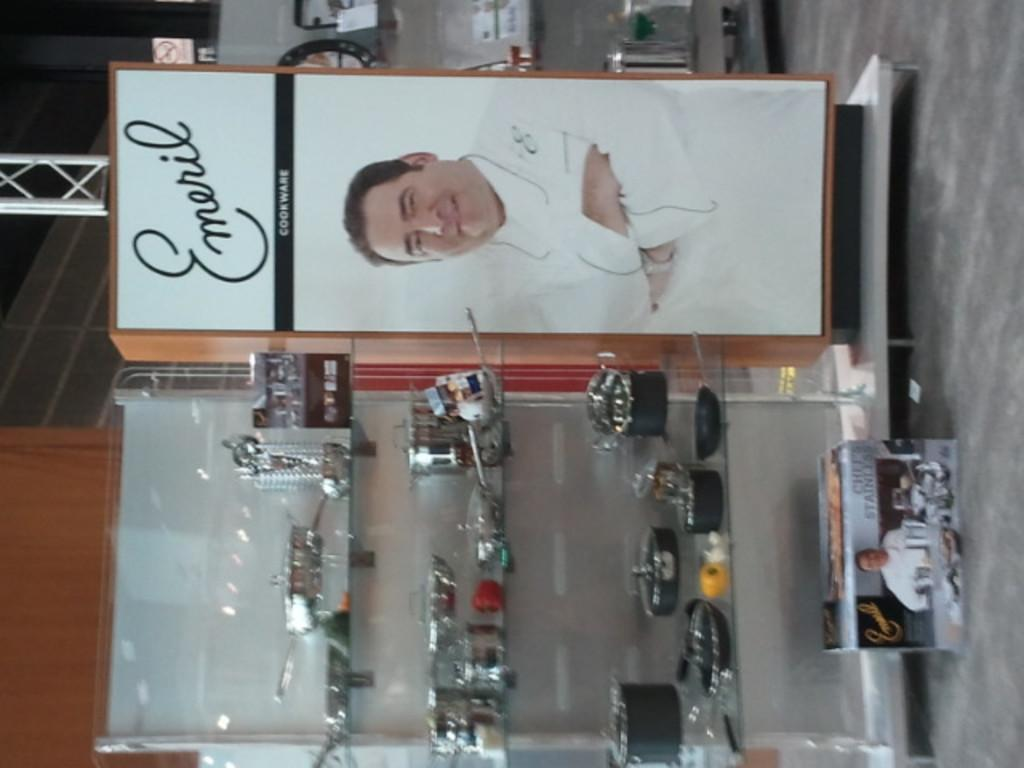What is the main object in the image? There is a hoarding in the image. What can be seen on the hoarding? The hoarding has a man's image on it, and there is writing on the top of the hoarding. What else is visible in the image? There is a glass rack in the image, and steel items are placed on the glass rack. What type of authority figure is depicted on the hoarding? There is no authority figure depicted on the hoarding; it features a man's image, but no indication of authority is provided. What is the texture of the hoarding? The texture of the hoarding cannot be determined from the image alone, as it is a two-dimensional representation. 